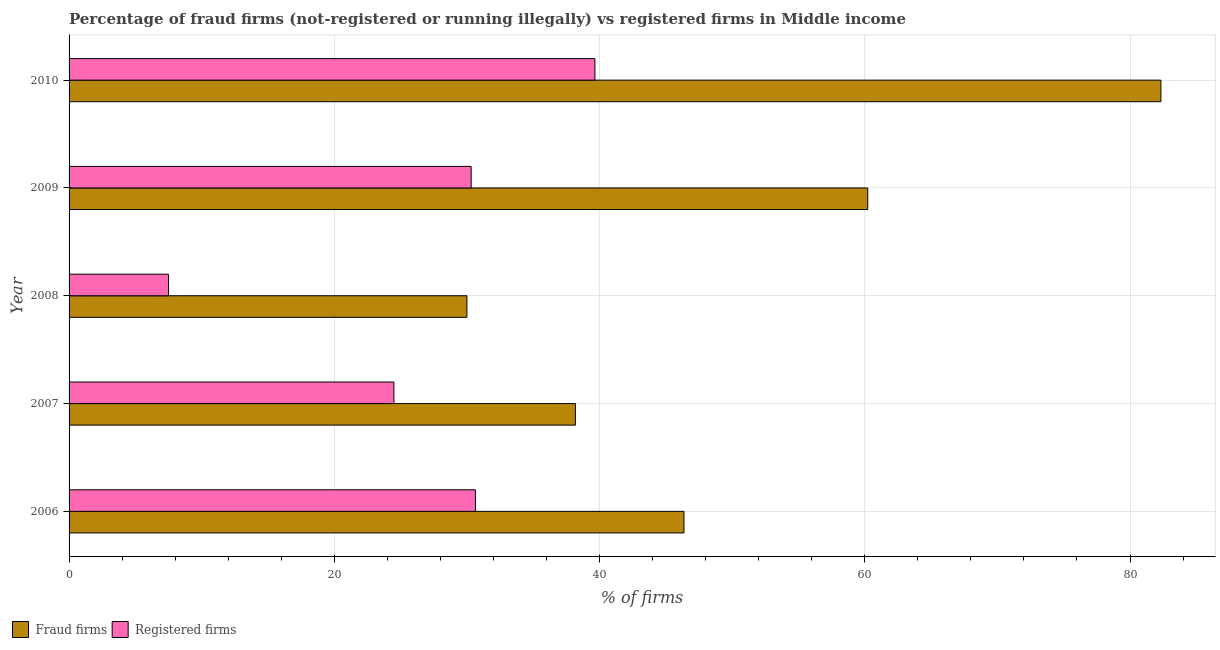How many different coloured bars are there?
Give a very brief answer. 2. How many groups of bars are there?
Your response must be concise. 5. Are the number of bars on each tick of the Y-axis equal?
Give a very brief answer. Yes. How many bars are there on the 4th tick from the top?
Provide a succinct answer. 2. How many bars are there on the 5th tick from the bottom?
Offer a very short reply. 2. What is the percentage of registered firms in 2010?
Your response must be concise. 39.65. Across all years, what is the maximum percentage of fraud firms?
Keep it short and to the point. 82.33. In which year was the percentage of fraud firms maximum?
Offer a very short reply. 2010. What is the total percentage of registered firms in the graph?
Provide a succinct answer. 132.6. What is the difference between the percentage of registered firms in 2008 and that in 2009?
Provide a short and direct response. -22.82. What is the difference between the percentage of fraud firms in 2010 and the percentage of registered firms in 2009?
Offer a terse response. 52.01. What is the average percentage of fraud firms per year?
Give a very brief answer. 51.42. In the year 2010, what is the difference between the percentage of registered firms and percentage of fraud firms?
Provide a succinct answer. -42.68. What is the ratio of the percentage of fraud firms in 2008 to that in 2009?
Offer a terse response. 0.5. What is the difference between the highest and the second highest percentage of registered firms?
Provide a succinct answer. 9.01. What is the difference between the highest and the lowest percentage of registered firms?
Provide a succinct answer. 32.15. In how many years, is the percentage of fraud firms greater than the average percentage of fraud firms taken over all years?
Your response must be concise. 2. What does the 1st bar from the top in 2009 represents?
Offer a very short reply. Registered firms. What does the 1st bar from the bottom in 2007 represents?
Your answer should be very brief. Fraud firms. Are all the bars in the graph horizontal?
Your response must be concise. Yes. What is the difference between two consecutive major ticks on the X-axis?
Make the answer very short. 20. Does the graph contain any zero values?
Make the answer very short. No. Where does the legend appear in the graph?
Offer a very short reply. Bottom left. How many legend labels are there?
Offer a terse response. 2. How are the legend labels stacked?
Provide a succinct answer. Horizontal. What is the title of the graph?
Offer a terse response. Percentage of fraud firms (not-registered or running illegally) vs registered firms in Middle income. What is the label or title of the X-axis?
Your answer should be compact. % of firms. What is the label or title of the Y-axis?
Give a very brief answer. Year. What is the % of firms of Fraud firms in 2006?
Give a very brief answer. 46.36. What is the % of firms in Registered firms in 2006?
Give a very brief answer. 30.64. What is the % of firms of Fraud firms in 2007?
Your answer should be very brief. 38.18. What is the % of firms of Registered firms in 2007?
Your answer should be compact. 24.49. What is the % of firms in Fraud firms in 2008?
Keep it short and to the point. 30. What is the % of firms in Fraud firms in 2009?
Provide a succinct answer. 60.23. What is the % of firms of Registered firms in 2009?
Provide a short and direct response. 30.32. What is the % of firms of Fraud firms in 2010?
Offer a terse response. 82.33. What is the % of firms of Registered firms in 2010?
Your answer should be very brief. 39.65. Across all years, what is the maximum % of firms of Fraud firms?
Provide a short and direct response. 82.33. Across all years, what is the maximum % of firms in Registered firms?
Make the answer very short. 39.65. Across all years, what is the minimum % of firms of Fraud firms?
Offer a very short reply. 30. What is the total % of firms in Fraud firms in the graph?
Your answer should be very brief. 257.1. What is the total % of firms of Registered firms in the graph?
Offer a terse response. 132.6. What is the difference between the % of firms of Fraud firms in 2006 and that in 2007?
Give a very brief answer. 8.18. What is the difference between the % of firms in Registered firms in 2006 and that in 2007?
Make the answer very short. 6.15. What is the difference between the % of firms of Fraud firms in 2006 and that in 2008?
Provide a succinct answer. 16.36. What is the difference between the % of firms of Registered firms in 2006 and that in 2008?
Make the answer very short. 23.14. What is the difference between the % of firms of Fraud firms in 2006 and that in 2009?
Give a very brief answer. -13.86. What is the difference between the % of firms in Registered firms in 2006 and that in 2009?
Provide a succinct answer. 0.32. What is the difference between the % of firms in Fraud firms in 2006 and that in 2010?
Offer a very short reply. -35.97. What is the difference between the % of firms of Registered firms in 2006 and that in 2010?
Give a very brief answer. -9.01. What is the difference between the % of firms of Fraud firms in 2007 and that in 2008?
Offer a terse response. 8.18. What is the difference between the % of firms of Registered firms in 2007 and that in 2008?
Your answer should be compact. 16.99. What is the difference between the % of firms in Fraud firms in 2007 and that in 2009?
Your answer should be compact. -22.05. What is the difference between the % of firms in Registered firms in 2007 and that in 2009?
Provide a succinct answer. -5.83. What is the difference between the % of firms of Fraud firms in 2007 and that in 2010?
Your answer should be compact. -44.15. What is the difference between the % of firms in Registered firms in 2007 and that in 2010?
Keep it short and to the point. -15.16. What is the difference between the % of firms in Fraud firms in 2008 and that in 2009?
Provide a succinct answer. -30.23. What is the difference between the % of firms of Registered firms in 2008 and that in 2009?
Keep it short and to the point. -22.82. What is the difference between the % of firms of Fraud firms in 2008 and that in 2010?
Offer a very short reply. -52.33. What is the difference between the % of firms in Registered firms in 2008 and that in 2010?
Offer a terse response. -32.15. What is the difference between the % of firms of Fraud firms in 2009 and that in 2010?
Offer a terse response. -22.1. What is the difference between the % of firms of Registered firms in 2009 and that in 2010?
Provide a succinct answer. -9.33. What is the difference between the % of firms in Fraud firms in 2006 and the % of firms in Registered firms in 2007?
Make the answer very short. 21.87. What is the difference between the % of firms of Fraud firms in 2006 and the % of firms of Registered firms in 2008?
Your response must be concise. 38.86. What is the difference between the % of firms in Fraud firms in 2006 and the % of firms in Registered firms in 2009?
Ensure brevity in your answer.  16.04. What is the difference between the % of firms of Fraud firms in 2006 and the % of firms of Registered firms in 2010?
Offer a terse response. 6.71. What is the difference between the % of firms in Fraud firms in 2007 and the % of firms in Registered firms in 2008?
Give a very brief answer. 30.68. What is the difference between the % of firms in Fraud firms in 2007 and the % of firms in Registered firms in 2009?
Offer a terse response. 7.86. What is the difference between the % of firms of Fraud firms in 2007 and the % of firms of Registered firms in 2010?
Provide a succinct answer. -1.47. What is the difference between the % of firms of Fraud firms in 2008 and the % of firms of Registered firms in 2009?
Provide a short and direct response. -0.32. What is the difference between the % of firms of Fraud firms in 2008 and the % of firms of Registered firms in 2010?
Your answer should be very brief. -9.65. What is the difference between the % of firms of Fraud firms in 2009 and the % of firms of Registered firms in 2010?
Provide a succinct answer. 20.58. What is the average % of firms in Fraud firms per year?
Your response must be concise. 51.42. What is the average % of firms in Registered firms per year?
Your response must be concise. 26.52. In the year 2006, what is the difference between the % of firms of Fraud firms and % of firms of Registered firms?
Your answer should be compact. 15.72. In the year 2007, what is the difference between the % of firms of Fraud firms and % of firms of Registered firms?
Give a very brief answer. 13.69. In the year 2009, what is the difference between the % of firms in Fraud firms and % of firms in Registered firms?
Offer a very short reply. 29.91. In the year 2010, what is the difference between the % of firms of Fraud firms and % of firms of Registered firms?
Make the answer very short. 42.68. What is the ratio of the % of firms of Fraud firms in 2006 to that in 2007?
Provide a short and direct response. 1.21. What is the ratio of the % of firms of Registered firms in 2006 to that in 2007?
Provide a succinct answer. 1.25. What is the ratio of the % of firms of Fraud firms in 2006 to that in 2008?
Make the answer very short. 1.55. What is the ratio of the % of firms in Registered firms in 2006 to that in 2008?
Keep it short and to the point. 4.09. What is the ratio of the % of firms in Fraud firms in 2006 to that in 2009?
Your response must be concise. 0.77. What is the ratio of the % of firms of Registered firms in 2006 to that in 2009?
Give a very brief answer. 1.01. What is the ratio of the % of firms in Fraud firms in 2006 to that in 2010?
Your response must be concise. 0.56. What is the ratio of the % of firms of Registered firms in 2006 to that in 2010?
Offer a terse response. 0.77. What is the ratio of the % of firms in Fraud firms in 2007 to that in 2008?
Offer a very short reply. 1.27. What is the ratio of the % of firms of Registered firms in 2007 to that in 2008?
Offer a very short reply. 3.27. What is the ratio of the % of firms of Fraud firms in 2007 to that in 2009?
Make the answer very short. 0.63. What is the ratio of the % of firms in Registered firms in 2007 to that in 2009?
Provide a succinct answer. 0.81. What is the ratio of the % of firms of Fraud firms in 2007 to that in 2010?
Your answer should be very brief. 0.46. What is the ratio of the % of firms in Registered firms in 2007 to that in 2010?
Provide a short and direct response. 0.62. What is the ratio of the % of firms of Fraud firms in 2008 to that in 2009?
Your response must be concise. 0.5. What is the ratio of the % of firms in Registered firms in 2008 to that in 2009?
Ensure brevity in your answer.  0.25. What is the ratio of the % of firms in Fraud firms in 2008 to that in 2010?
Ensure brevity in your answer.  0.36. What is the ratio of the % of firms of Registered firms in 2008 to that in 2010?
Your answer should be very brief. 0.19. What is the ratio of the % of firms in Fraud firms in 2009 to that in 2010?
Keep it short and to the point. 0.73. What is the ratio of the % of firms in Registered firms in 2009 to that in 2010?
Ensure brevity in your answer.  0.76. What is the difference between the highest and the second highest % of firms of Fraud firms?
Offer a terse response. 22.1. What is the difference between the highest and the second highest % of firms of Registered firms?
Provide a short and direct response. 9.01. What is the difference between the highest and the lowest % of firms of Fraud firms?
Provide a succinct answer. 52.33. What is the difference between the highest and the lowest % of firms of Registered firms?
Your answer should be compact. 32.15. 